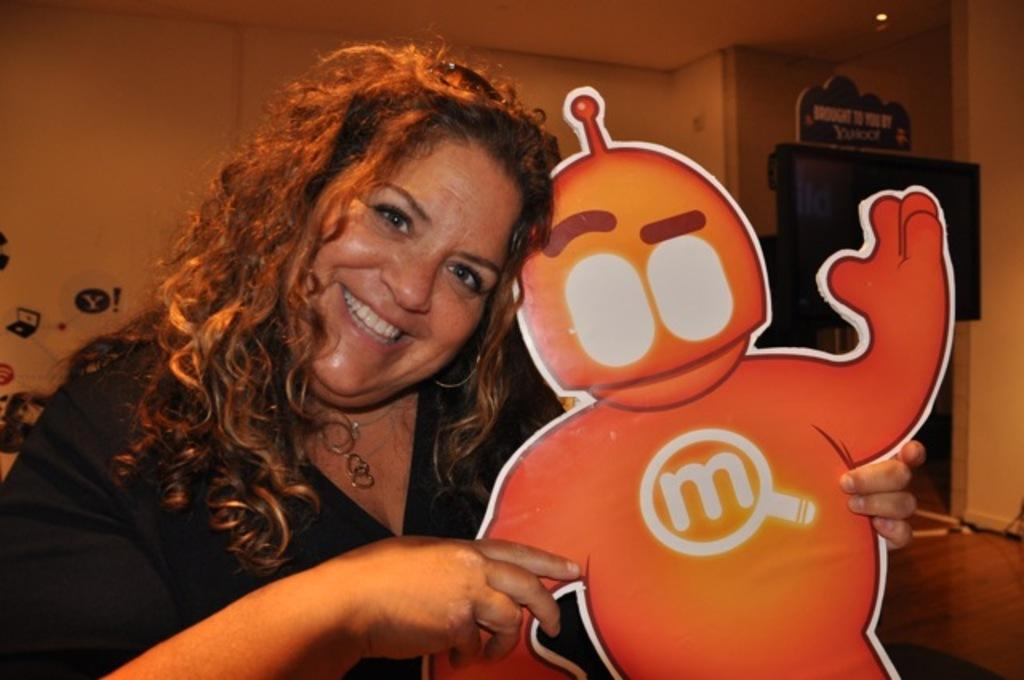<image>
Render a clear and concise summary of the photo. A woman holding a cutout of an alien android with a glowing lower case "m" on its chest. 